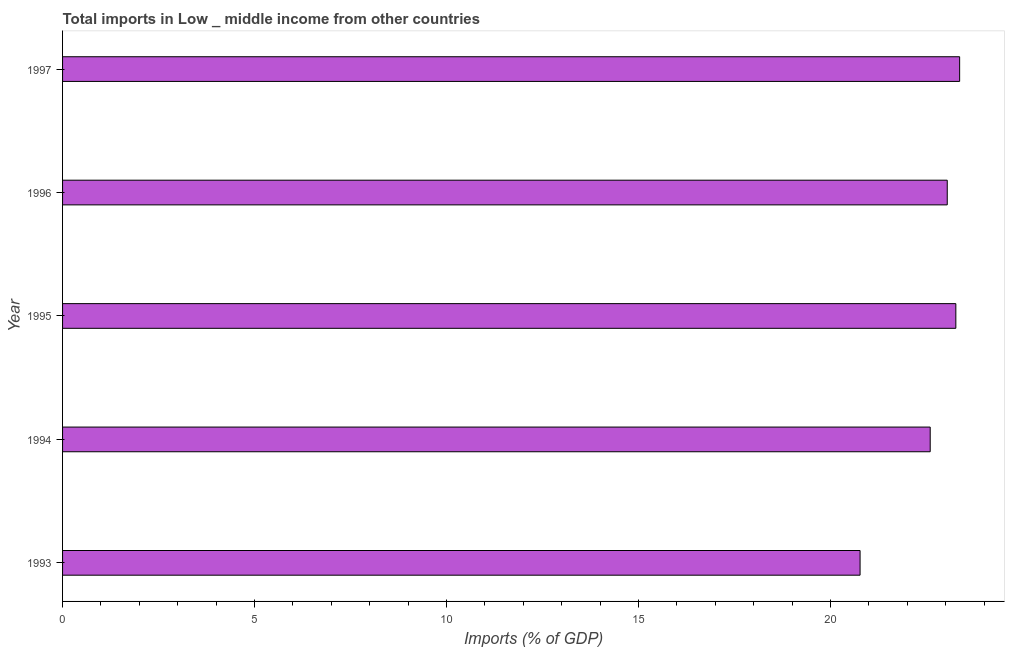Does the graph contain grids?
Offer a very short reply. No. What is the title of the graph?
Offer a very short reply. Total imports in Low _ middle income from other countries. What is the label or title of the X-axis?
Your response must be concise. Imports (% of GDP). What is the total imports in 1997?
Provide a short and direct response. 23.36. Across all years, what is the maximum total imports?
Give a very brief answer. 23.36. Across all years, what is the minimum total imports?
Your answer should be very brief. 20.77. In which year was the total imports maximum?
Offer a very short reply. 1997. What is the sum of the total imports?
Ensure brevity in your answer.  113.02. What is the difference between the total imports in 1994 and 1995?
Offer a very short reply. -0.67. What is the average total imports per year?
Make the answer very short. 22.6. What is the median total imports?
Ensure brevity in your answer.  23.04. What is the ratio of the total imports in 1993 to that in 1996?
Keep it short and to the point. 0.9. Is the total imports in 1995 less than that in 1997?
Ensure brevity in your answer.  Yes. What is the difference between the highest and the second highest total imports?
Your answer should be compact. 0.1. What is the difference between the highest and the lowest total imports?
Your answer should be compact. 2.59. In how many years, is the total imports greater than the average total imports taken over all years?
Offer a very short reply. 3. How many bars are there?
Give a very brief answer. 5. What is the difference between two consecutive major ticks on the X-axis?
Your response must be concise. 5. What is the Imports (% of GDP) in 1993?
Make the answer very short. 20.77. What is the Imports (% of GDP) of 1994?
Offer a very short reply. 22.59. What is the Imports (% of GDP) of 1995?
Offer a very short reply. 23.26. What is the Imports (% of GDP) of 1996?
Make the answer very short. 23.04. What is the Imports (% of GDP) in 1997?
Your answer should be very brief. 23.36. What is the difference between the Imports (% of GDP) in 1993 and 1994?
Make the answer very short. -1.83. What is the difference between the Imports (% of GDP) in 1993 and 1995?
Give a very brief answer. -2.49. What is the difference between the Imports (% of GDP) in 1993 and 1996?
Offer a very short reply. -2.27. What is the difference between the Imports (% of GDP) in 1993 and 1997?
Keep it short and to the point. -2.59. What is the difference between the Imports (% of GDP) in 1994 and 1995?
Your answer should be very brief. -0.67. What is the difference between the Imports (% of GDP) in 1994 and 1996?
Your answer should be very brief. -0.44. What is the difference between the Imports (% of GDP) in 1994 and 1997?
Offer a terse response. -0.77. What is the difference between the Imports (% of GDP) in 1995 and 1996?
Ensure brevity in your answer.  0.22. What is the difference between the Imports (% of GDP) in 1995 and 1997?
Offer a terse response. -0.1. What is the difference between the Imports (% of GDP) in 1996 and 1997?
Your answer should be compact. -0.32. What is the ratio of the Imports (% of GDP) in 1993 to that in 1994?
Offer a very short reply. 0.92. What is the ratio of the Imports (% of GDP) in 1993 to that in 1995?
Make the answer very short. 0.89. What is the ratio of the Imports (% of GDP) in 1993 to that in 1996?
Your answer should be very brief. 0.9. What is the ratio of the Imports (% of GDP) in 1993 to that in 1997?
Offer a terse response. 0.89. What is the ratio of the Imports (% of GDP) in 1994 to that in 1995?
Provide a succinct answer. 0.97. What is the ratio of the Imports (% of GDP) in 1994 to that in 1996?
Give a very brief answer. 0.98. What is the ratio of the Imports (% of GDP) in 1995 to that in 1997?
Make the answer very short. 1. What is the ratio of the Imports (% of GDP) in 1996 to that in 1997?
Provide a short and direct response. 0.99. 